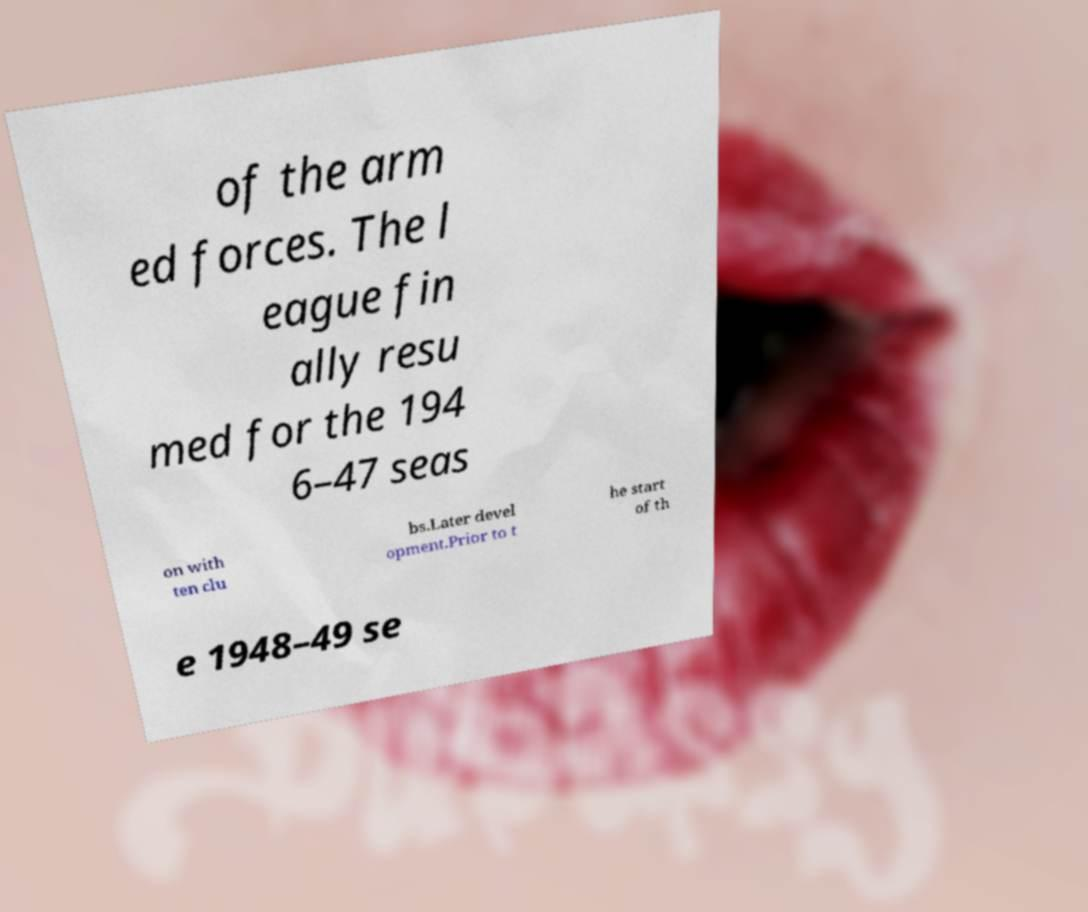Could you assist in decoding the text presented in this image and type it out clearly? of the arm ed forces. The l eague fin ally resu med for the 194 6–47 seas on with ten clu bs.Later devel opment.Prior to t he start of th e 1948–49 se 